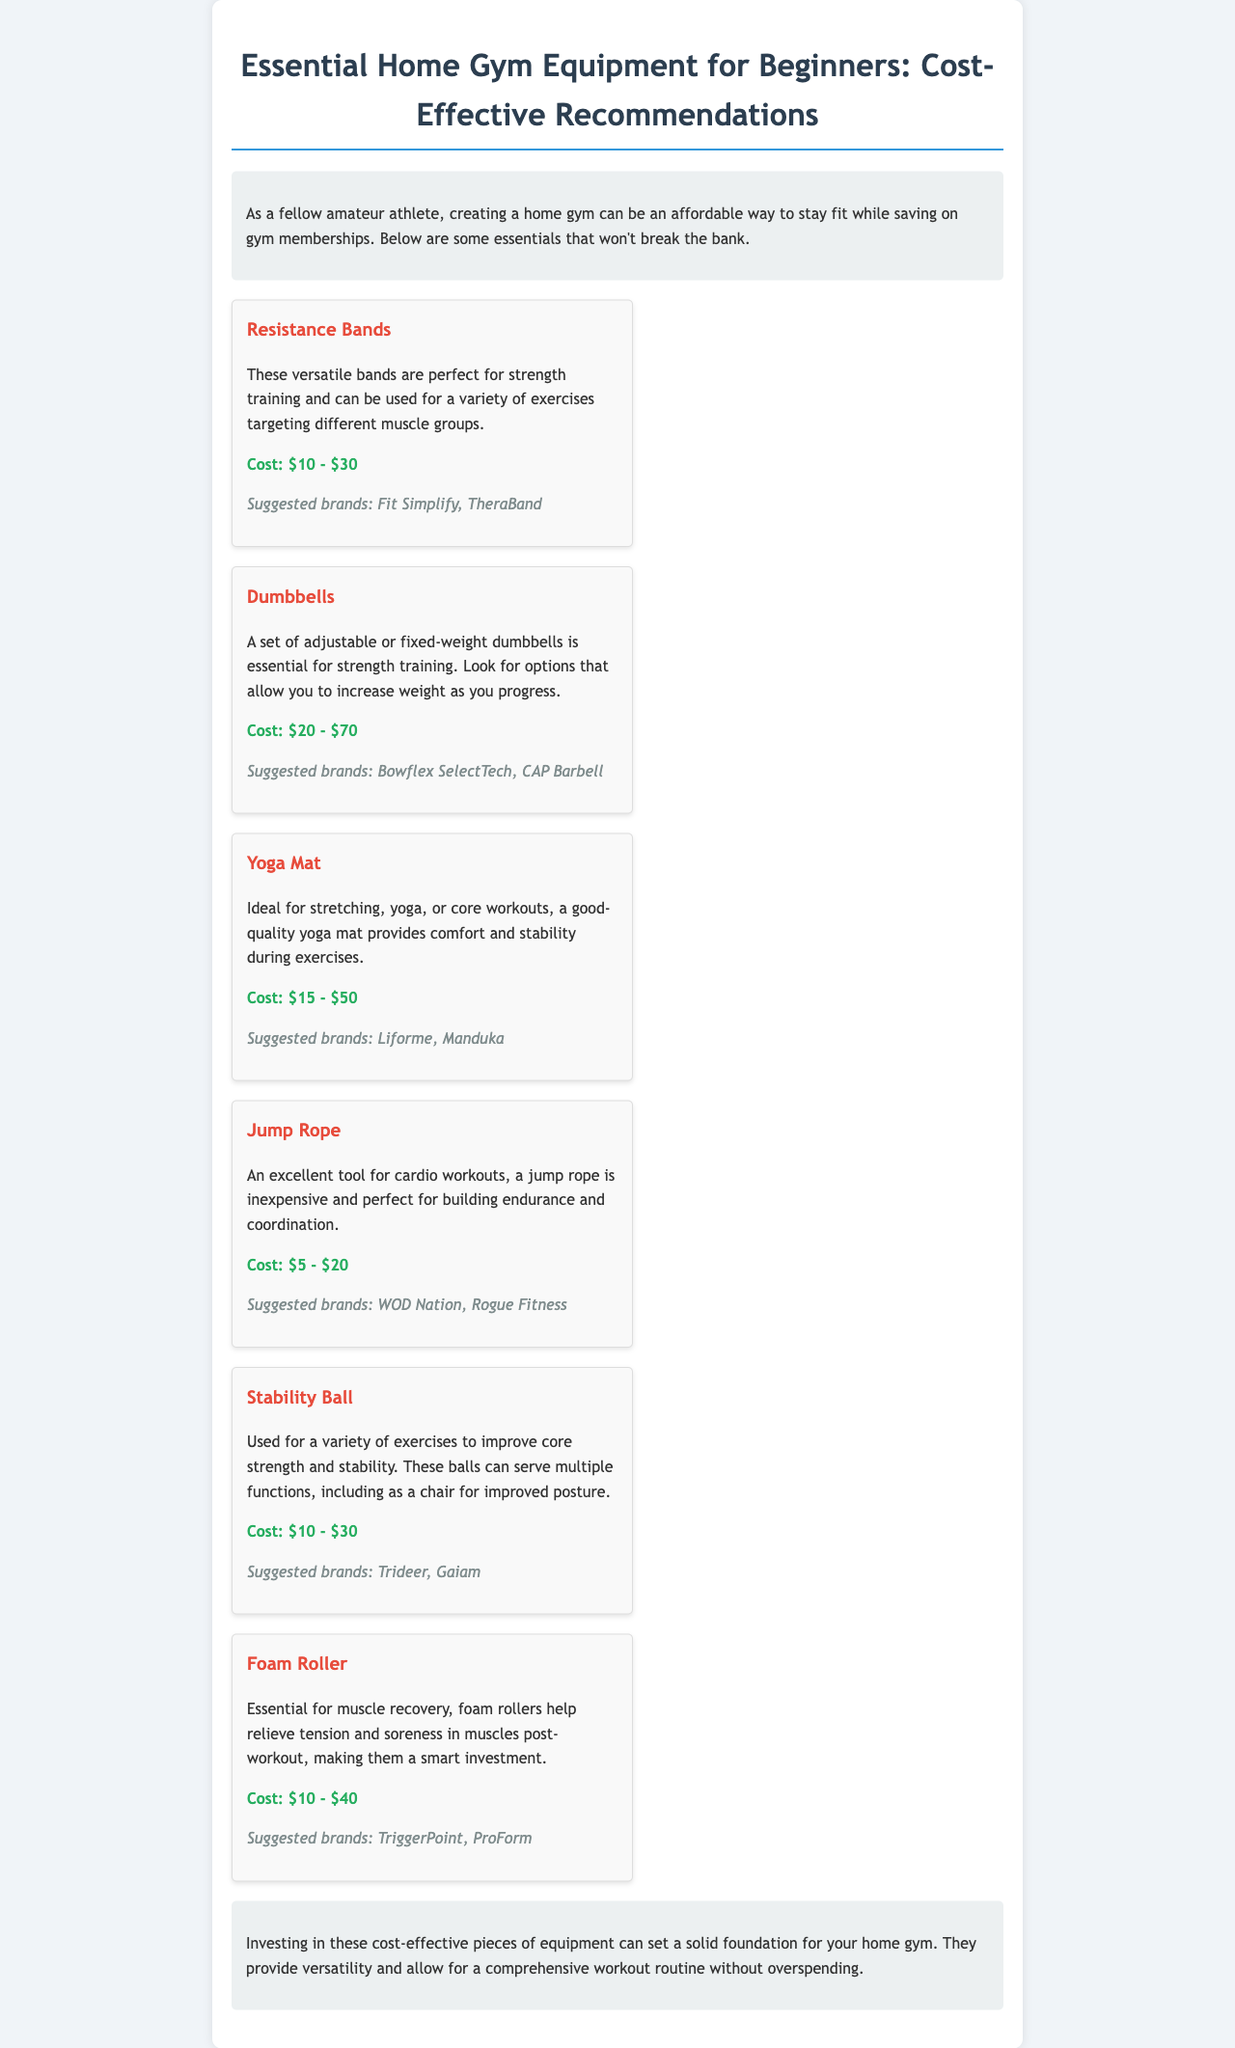What is the cost range for Resistance Bands? The cost range for Resistance Bands is provided in the document, which states that they cost between $10 and $30.
Answer: $10 - $30 Which brand is suggested for Dumbbells? The document lists suggested brands for Dumbbells, and one of them mentioned is Bowflex SelectTech.
Answer: Bowflex SelectTech How many types of equipment are listed in the document? The document details six different types of home gym equipment for beginners.
Answer: 6 What is the primary use of a Yoga Mat? The document notes that a Yoga Mat is ideal for stretching, yoga, or core workouts.
Answer: Stretching, yoga, or core workouts What equipment is recommended for cardio workouts? According to the document, a Jump Rope is recommended for cardio workouts.
Answer: Jump Rope What is stated as an essential feature of a Stability Ball? The document mentions that a Stability Ball is used to improve core strength and stability.
Answer: Improve core strength and stability What benefit does a Foam Roller provide? The document states that Foam Rollers help relieve tension and soreness in muscles post-workout.
Answer: Relieve tension and soreness What is the purpose of this document? The purpose of the document is to provide cost-effective recommendations for beginners setting up a home gym.
Answer: Cost-effective recommendations for home gym 